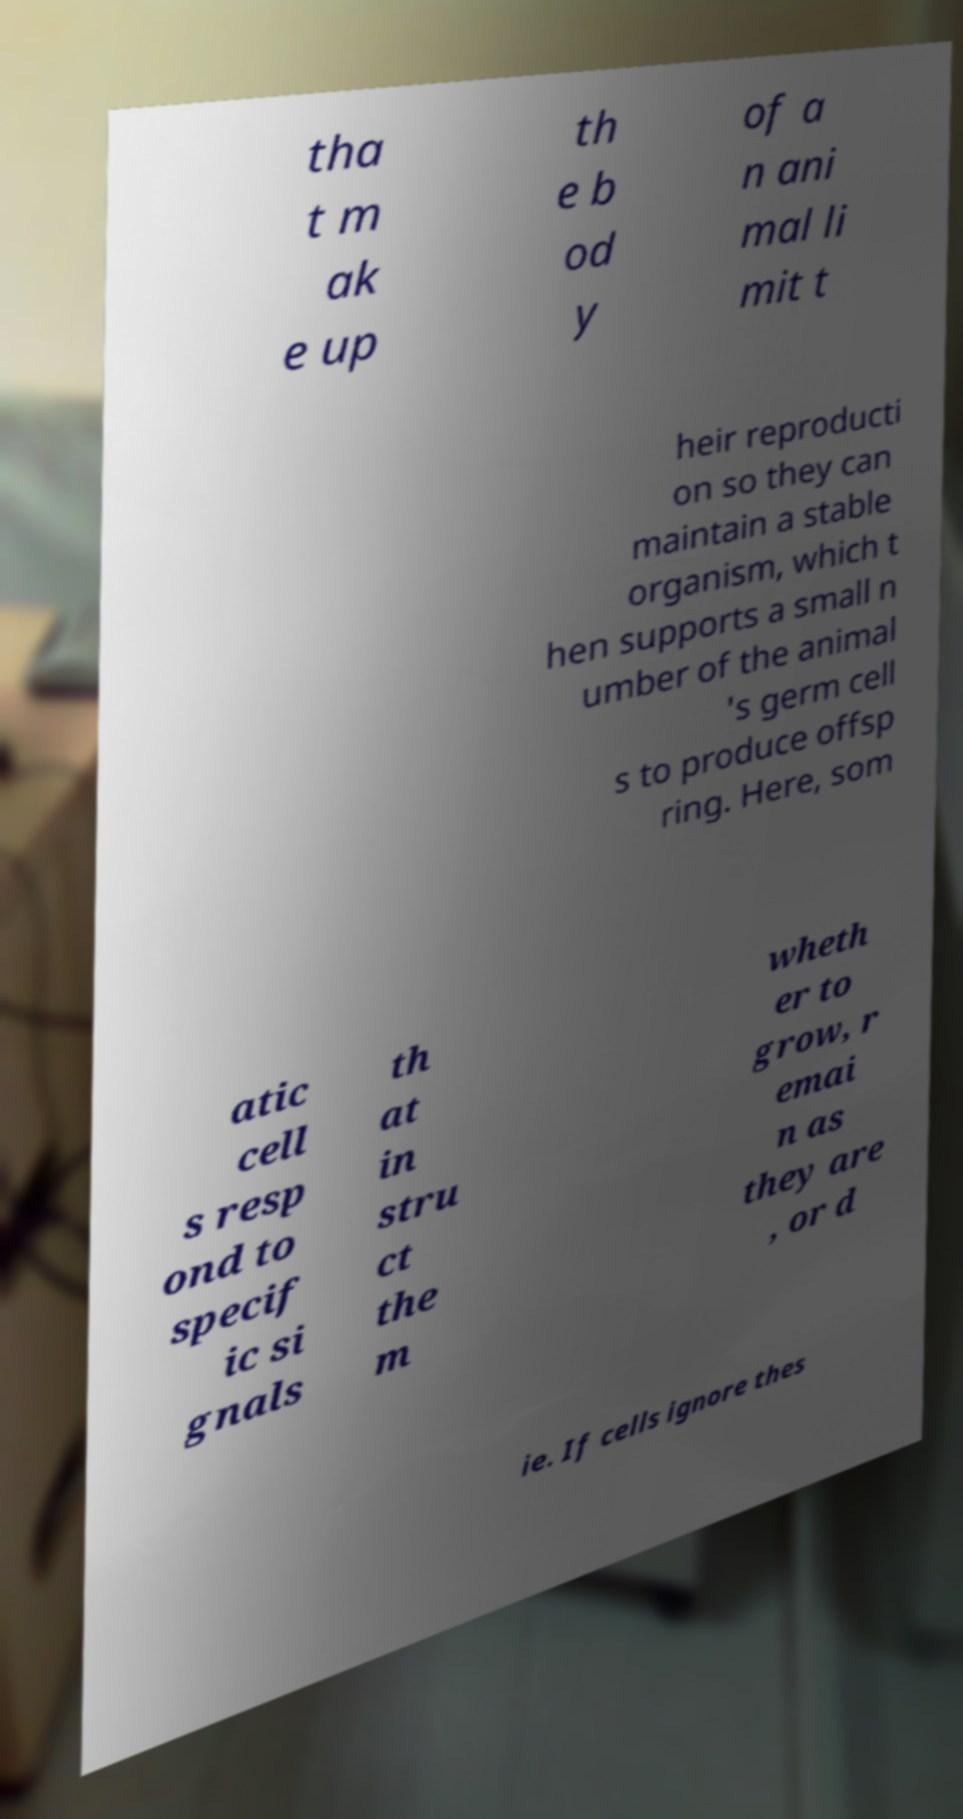What messages or text are displayed in this image? I need them in a readable, typed format. tha t m ak e up th e b od y of a n ani mal li mit t heir reproducti on so they can maintain a stable organism, which t hen supports a small n umber of the animal 's germ cell s to produce offsp ring. Here, som atic cell s resp ond to specif ic si gnals th at in stru ct the m wheth er to grow, r emai n as they are , or d ie. If cells ignore thes 